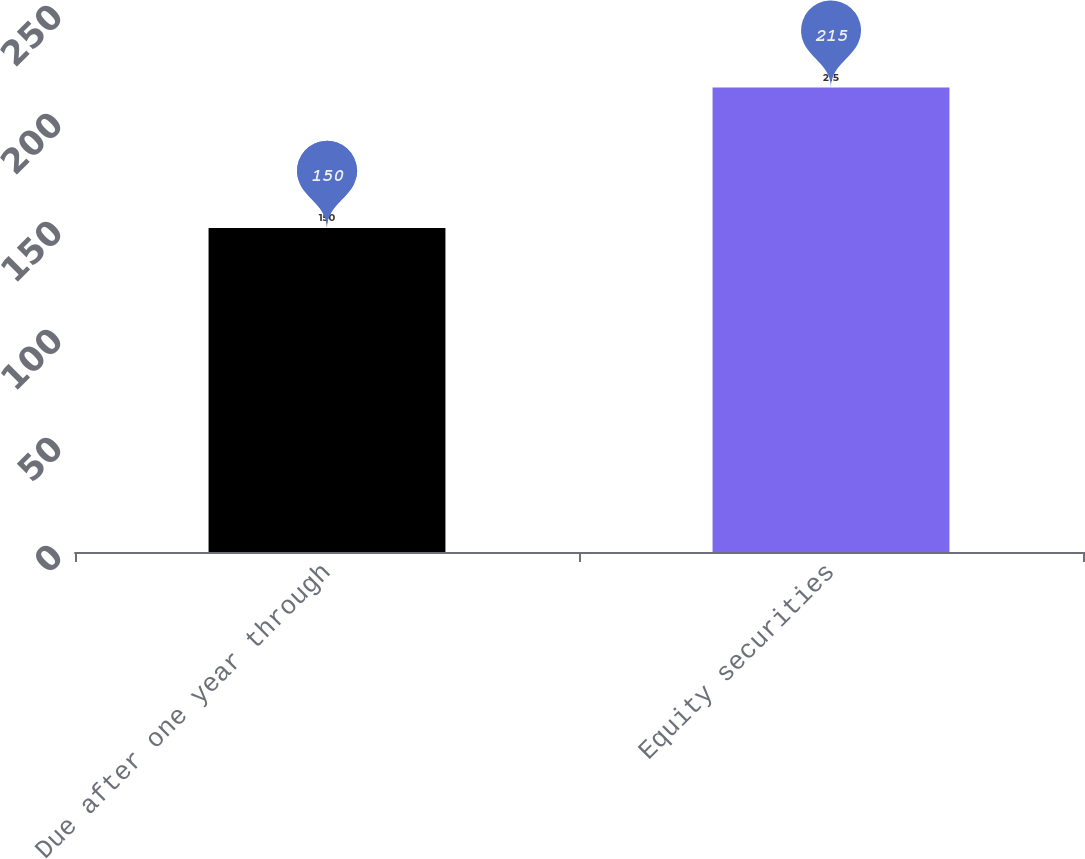Convert chart to OTSL. <chart><loc_0><loc_0><loc_500><loc_500><bar_chart><fcel>Due after one year through<fcel>Equity securities<nl><fcel>150<fcel>215<nl></chart> 